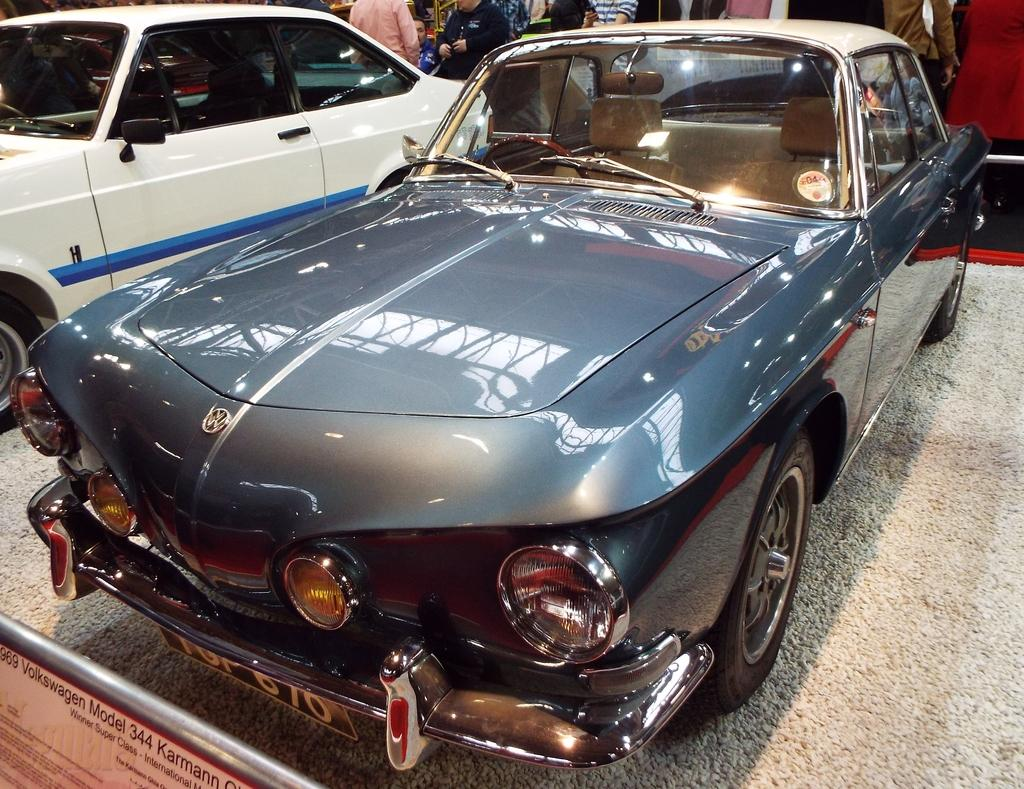How many cars are visible in the image? There are two cars in the image. What color is one of the cars? One of the cars is gray. Can you describe the scene in the background of the image? There is a group of people in the background of the image. How far away is the cannon from the gray car in the image? There is no cannon present in the image, so it cannot be determined how far away it would be from the gray car. 